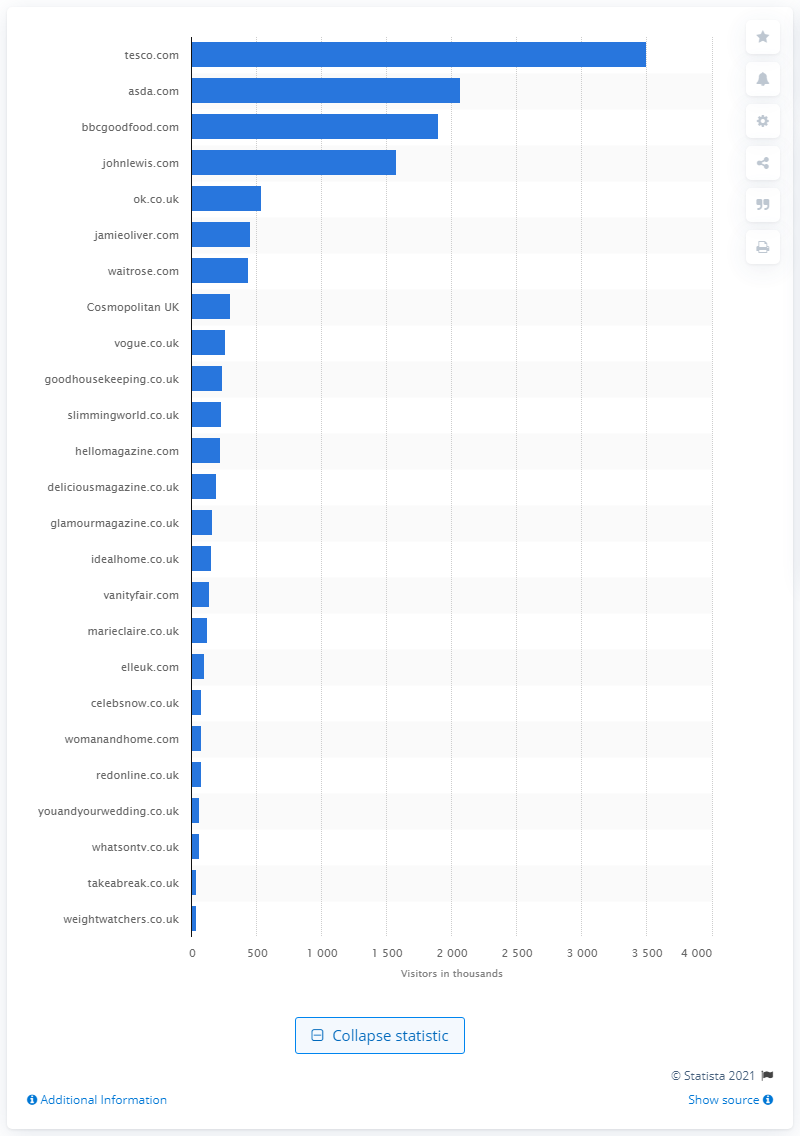Point out several critical features in this image. The website that was the most visited by women's magazines in the UK was Tesco.com. 